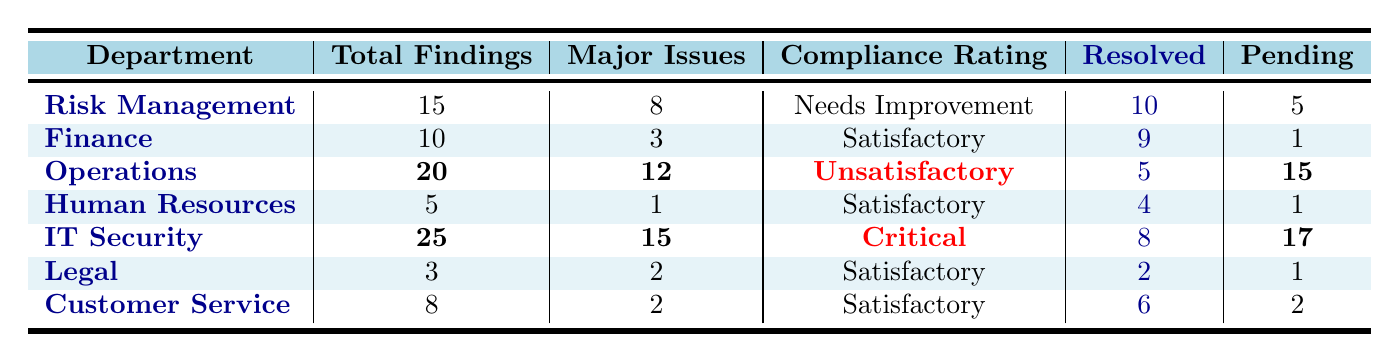What is the total number of findings reported in the IT Security department? The IT Security department has a total of 25 findings listed in the table.
Answer: 25 How many major issues were identified in the Operations department? The Operations department has 12 major issues noted in the table.
Answer: 12 Does the Finance department have any pending findings? Yes, the Finance department has 1 pending finding according to the table.
Answer: Yes What is the compliance rating of the Risk Management department? The compliance rating for the Risk Management department is "Needs Improvement" as stated in the table.
Answer: Needs Improvement Which department has the highest number of pending findings? The IT Security department has the highest pending findings at 17, compared to others.
Answer: IT Security What is the average number of resolved findings across all departments? Total resolved findings are (10 + 9 + 5 + 4 + 8 + 2 + 6) = 44. There are 7 departments, so the average is 44/7 = approximately 6.29.
Answer: Approximately 6.29 How many departments have a compliance rating of "Satisfactory"? There are 4 departments with a compliance rating of "Satisfactory": Finance, Human Resources, Legal, and Customer Service.
Answer: 4 What is the sum of total findings for departments rated "Satisfactory"? The total findings for departments rated "Satisfactory" are (10 + 5 + 3 + 8) = 26.
Answer: 26 Which department resolved the fewest number of findings? The Operations department resolved the fewest findings at 5 compared to others.
Answer: Operations If we combine the major issues of the Risk Management and IT Security departments, what is the total? Adding the major issues from Risk Management (8) and IT Security (15) gives 8 + 15 = 23.
Answer: 23 How many total findings are there across departments rated "Unsatisfactory" or "Critical"? There are 20 findings from Operations and 25 from IT Security, totaling 20 + 25 = 45 findings.
Answer: 45 Is there any department that had zero unresolved findings? No, all departments have pending findings, with at least one department having unresolved issues.
Answer: No 